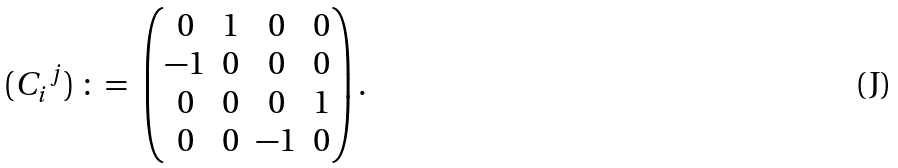Convert formula to latex. <formula><loc_0><loc_0><loc_500><loc_500>( { C _ { i } } ^ { j } ) \ \colon = \ \begin{pmatrix} 0 & 1 & 0 & 0 \\ - 1 & 0 & 0 & 0 \\ 0 & 0 & 0 & 1 \\ 0 & 0 & - 1 & 0 \end{pmatrix} .</formula> 